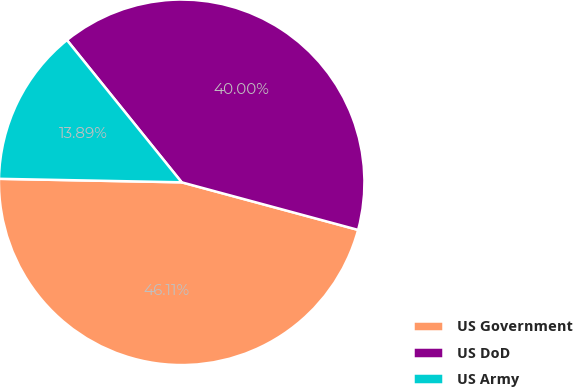Convert chart. <chart><loc_0><loc_0><loc_500><loc_500><pie_chart><fcel>US Government<fcel>US DoD<fcel>US Army<nl><fcel>46.11%<fcel>40.0%<fcel>13.89%<nl></chart> 